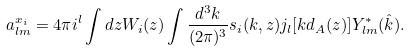<formula> <loc_0><loc_0><loc_500><loc_500>a _ { l m } ^ { x _ { i } } = 4 \pi i ^ { l } \int d z W _ { i } ( z ) \int \frac { d ^ { 3 } k } { ( 2 \pi ) ^ { 3 } } s _ { i } ( k , z ) j _ { l } [ k d _ { A } ( z ) ] Y _ { l m } ^ { * } ( \hat { k } ) .</formula> 